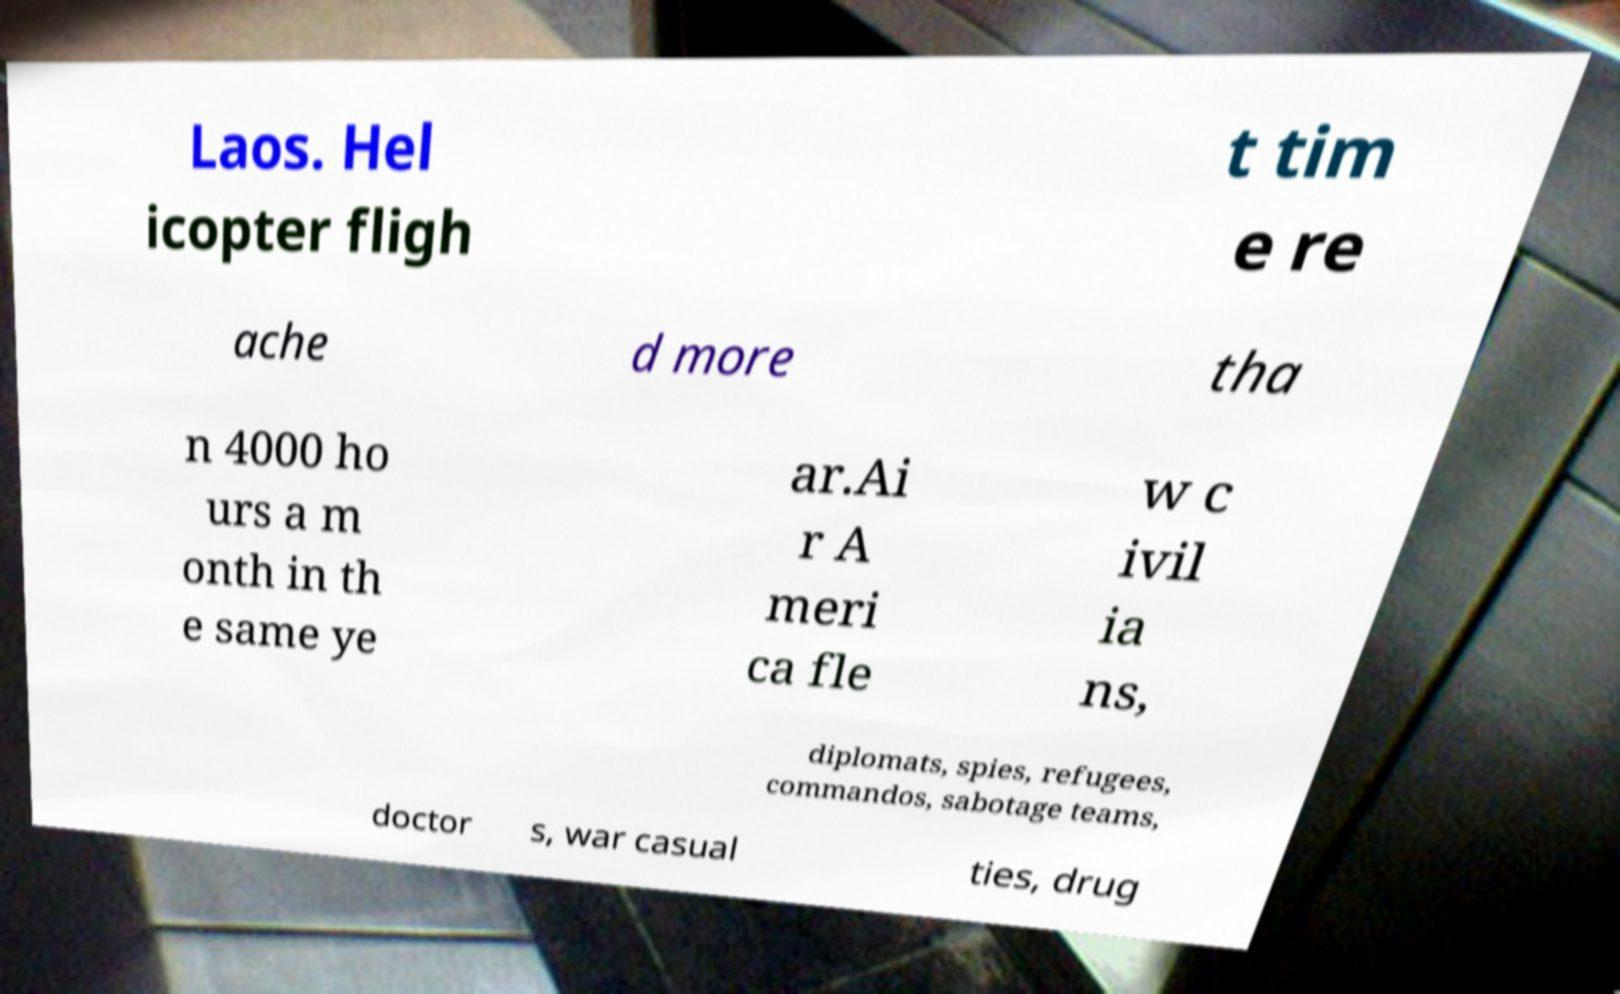Can you read and provide the text displayed in the image?This photo seems to have some interesting text. Can you extract and type it out for me? Laos. Hel icopter fligh t tim e re ache d more tha n 4000 ho urs a m onth in th e same ye ar.Ai r A meri ca fle w c ivil ia ns, diplomats, spies, refugees, commandos, sabotage teams, doctor s, war casual ties, drug 